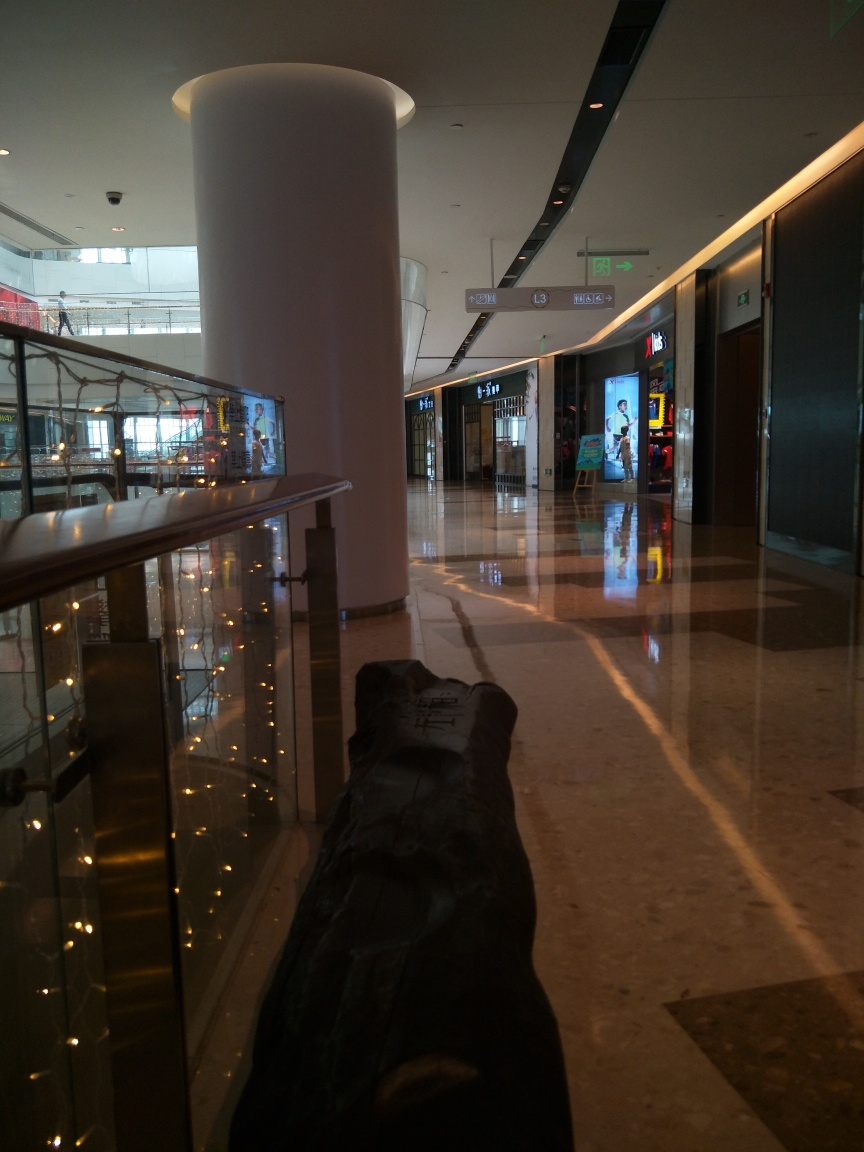Can you tell me what kind of place this is? The image depicts an indoor setting, likely a shopping mall or commercial center, characterized by retail store entrances, bright overhead lighting, and a spacious corridor for pedestrians. 